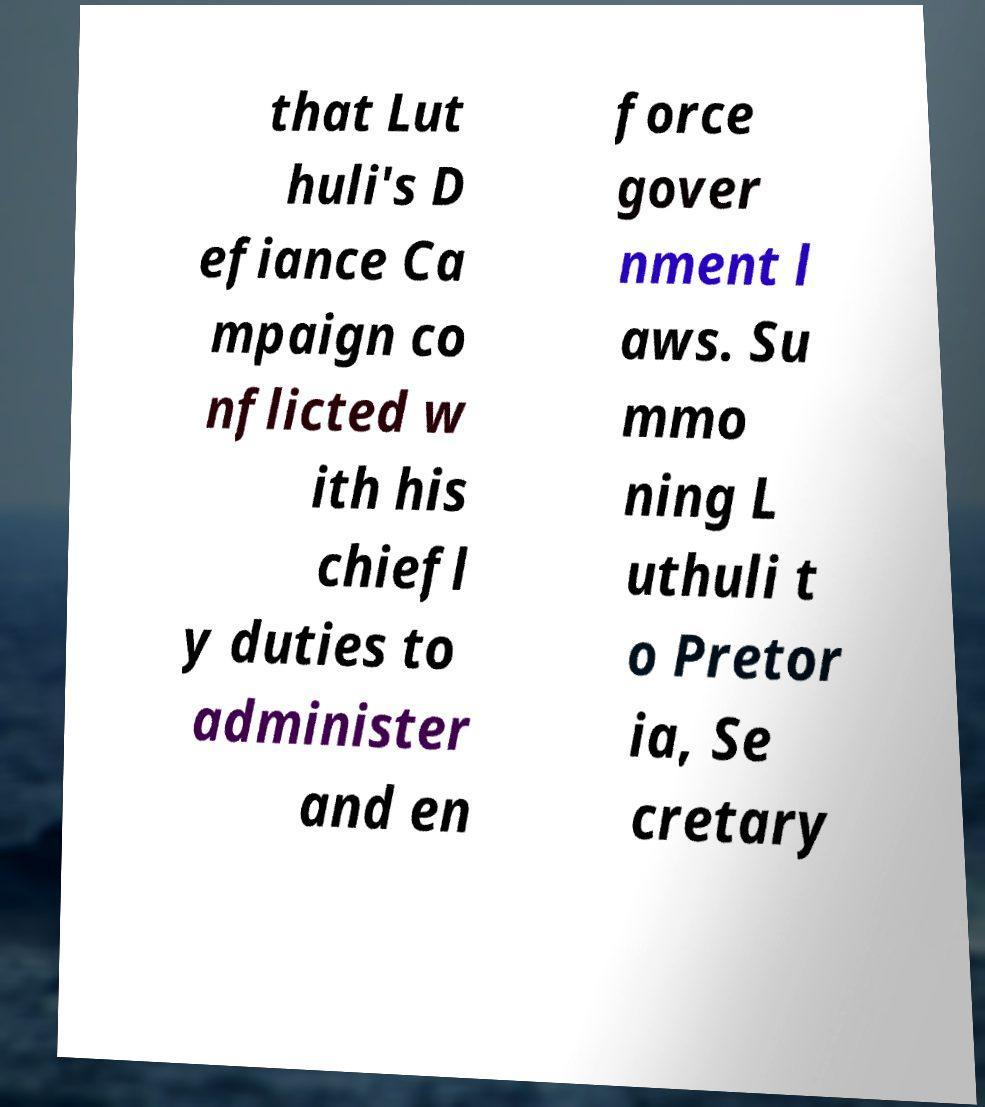For documentation purposes, I need the text within this image transcribed. Could you provide that? that Lut huli's D efiance Ca mpaign co nflicted w ith his chiefl y duties to administer and en force gover nment l aws. Su mmo ning L uthuli t o Pretor ia, Se cretary 